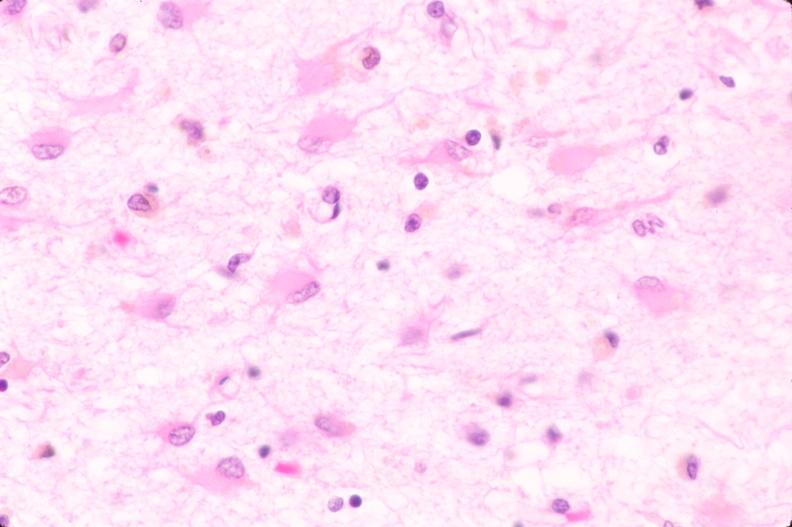where is this?
Answer the question using a single word or phrase. Nervous 